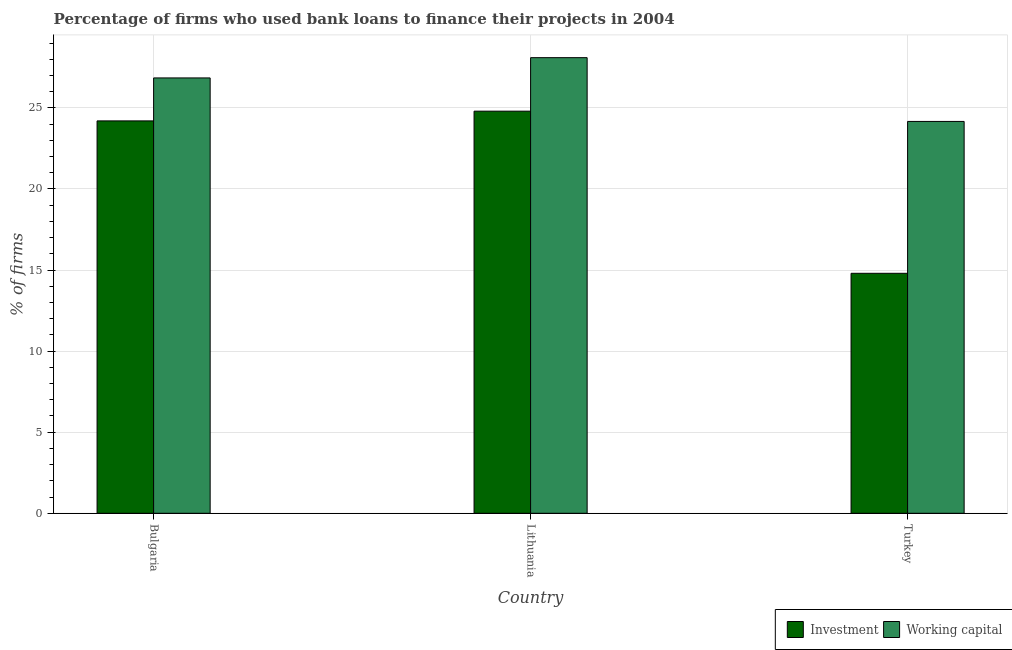How many different coloured bars are there?
Your response must be concise. 2. How many bars are there on the 2nd tick from the left?
Offer a very short reply. 2. In how many cases, is the number of bars for a given country not equal to the number of legend labels?
Offer a terse response. 0. What is the percentage of firms using banks to finance working capital in Turkey?
Your answer should be compact. 24.17. Across all countries, what is the maximum percentage of firms using banks to finance working capital?
Give a very brief answer. 28.1. In which country was the percentage of firms using banks to finance investment maximum?
Your answer should be compact. Lithuania. What is the total percentage of firms using banks to finance working capital in the graph?
Provide a short and direct response. 79.12. What is the difference between the percentage of firms using banks to finance working capital in Bulgaria and that in Turkey?
Ensure brevity in your answer.  2.68. What is the difference between the percentage of firms using banks to finance working capital in Bulgaria and the percentage of firms using banks to finance investment in Lithuania?
Your response must be concise. 2.05. What is the average percentage of firms using banks to finance investment per country?
Provide a succinct answer. 21.27. What is the difference between the percentage of firms using banks to finance working capital and percentage of firms using banks to finance investment in Lithuania?
Ensure brevity in your answer.  3.3. What is the ratio of the percentage of firms using banks to finance working capital in Lithuania to that in Turkey?
Provide a short and direct response. 1.16. What is the difference between the highest and the second highest percentage of firms using banks to finance working capital?
Offer a terse response. 1.25. What is the difference between the highest and the lowest percentage of firms using banks to finance investment?
Give a very brief answer. 10. In how many countries, is the percentage of firms using banks to finance investment greater than the average percentage of firms using banks to finance investment taken over all countries?
Provide a succinct answer. 2. What does the 1st bar from the left in Turkey represents?
Your answer should be very brief. Investment. What does the 1st bar from the right in Lithuania represents?
Keep it short and to the point. Working capital. How many countries are there in the graph?
Your response must be concise. 3. What is the difference between two consecutive major ticks on the Y-axis?
Offer a very short reply. 5. Are the values on the major ticks of Y-axis written in scientific E-notation?
Give a very brief answer. No. Does the graph contain grids?
Keep it short and to the point. Yes. Where does the legend appear in the graph?
Provide a succinct answer. Bottom right. How many legend labels are there?
Provide a succinct answer. 2. How are the legend labels stacked?
Give a very brief answer. Horizontal. What is the title of the graph?
Provide a short and direct response. Percentage of firms who used bank loans to finance their projects in 2004. What is the label or title of the X-axis?
Provide a succinct answer. Country. What is the label or title of the Y-axis?
Offer a very short reply. % of firms. What is the % of firms in Investment in Bulgaria?
Give a very brief answer. 24.2. What is the % of firms in Working capital in Bulgaria?
Your answer should be very brief. 26.85. What is the % of firms of Investment in Lithuania?
Your answer should be compact. 24.8. What is the % of firms of Working capital in Lithuania?
Your answer should be very brief. 28.1. What is the % of firms in Investment in Turkey?
Your response must be concise. 14.8. What is the % of firms of Working capital in Turkey?
Give a very brief answer. 24.17. Across all countries, what is the maximum % of firms in Investment?
Your answer should be very brief. 24.8. Across all countries, what is the maximum % of firms of Working capital?
Make the answer very short. 28.1. Across all countries, what is the minimum % of firms in Investment?
Your response must be concise. 14.8. Across all countries, what is the minimum % of firms in Working capital?
Your response must be concise. 24.17. What is the total % of firms of Investment in the graph?
Make the answer very short. 63.8. What is the total % of firms of Working capital in the graph?
Your answer should be very brief. 79.12. What is the difference between the % of firms in Working capital in Bulgaria and that in Lithuania?
Make the answer very short. -1.25. What is the difference between the % of firms of Working capital in Bulgaria and that in Turkey?
Keep it short and to the point. 2.68. What is the difference between the % of firms in Working capital in Lithuania and that in Turkey?
Make the answer very short. 3.93. What is the difference between the % of firms in Investment in Bulgaria and the % of firms in Working capital in Lithuania?
Offer a terse response. -3.9. What is the difference between the % of firms in Investment in Lithuania and the % of firms in Working capital in Turkey?
Provide a succinct answer. 0.63. What is the average % of firms of Investment per country?
Ensure brevity in your answer.  21.27. What is the average % of firms in Working capital per country?
Make the answer very short. 26.37. What is the difference between the % of firms of Investment and % of firms of Working capital in Bulgaria?
Give a very brief answer. -2.65. What is the difference between the % of firms in Investment and % of firms in Working capital in Turkey?
Provide a short and direct response. -9.37. What is the ratio of the % of firms of Investment in Bulgaria to that in Lithuania?
Provide a short and direct response. 0.98. What is the ratio of the % of firms in Working capital in Bulgaria to that in Lithuania?
Provide a succinct answer. 0.96. What is the ratio of the % of firms in Investment in Bulgaria to that in Turkey?
Ensure brevity in your answer.  1.64. What is the ratio of the % of firms in Working capital in Bulgaria to that in Turkey?
Keep it short and to the point. 1.11. What is the ratio of the % of firms in Investment in Lithuania to that in Turkey?
Keep it short and to the point. 1.68. What is the ratio of the % of firms in Working capital in Lithuania to that in Turkey?
Ensure brevity in your answer.  1.16. What is the difference between the highest and the second highest % of firms in Investment?
Your answer should be very brief. 0.6. What is the difference between the highest and the lowest % of firms of Working capital?
Your answer should be compact. 3.93. 